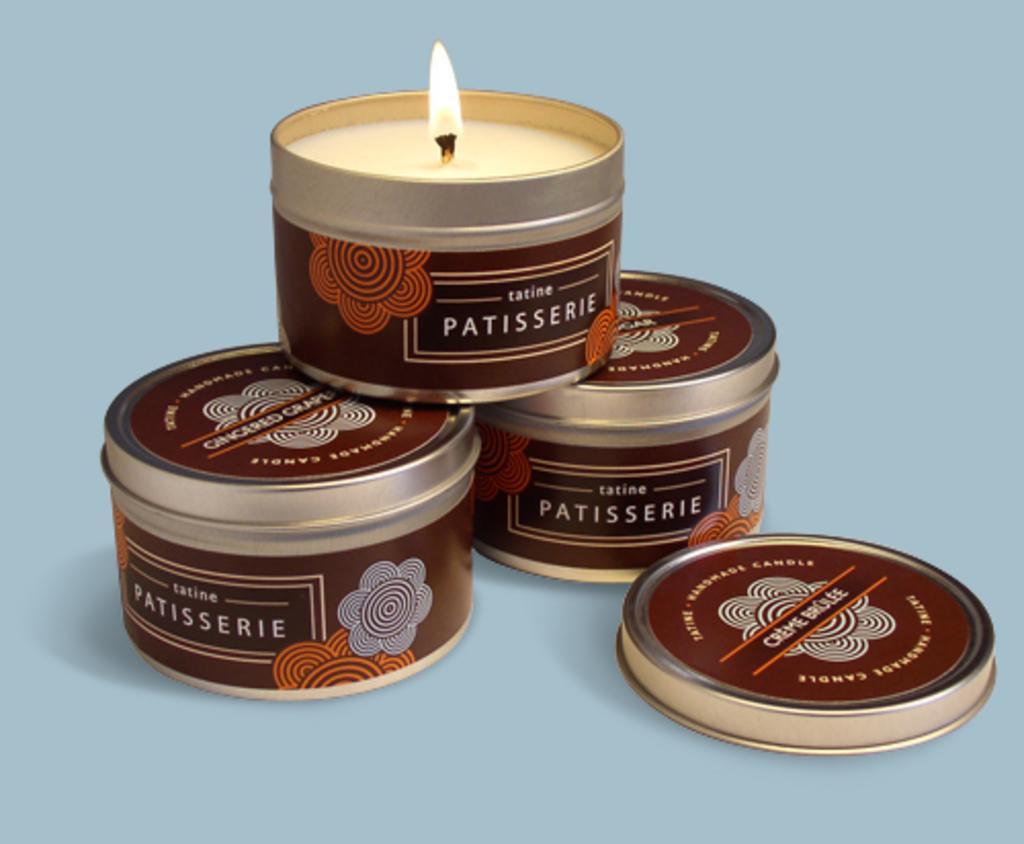Can you describe this image briefly? In this image I can see three candle holders with lids. These are placed on a blue surface. 